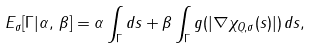<formula> <loc_0><loc_0><loc_500><loc_500>E _ { \sigma } [ \Gamma | \alpha , \, \beta ] = \alpha \int _ { \Gamma } d s + \beta \int _ { \Gamma } g ( | \nabla \chi _ { Q , \sigma } ( s ) | ) \, d s ,</formula> 